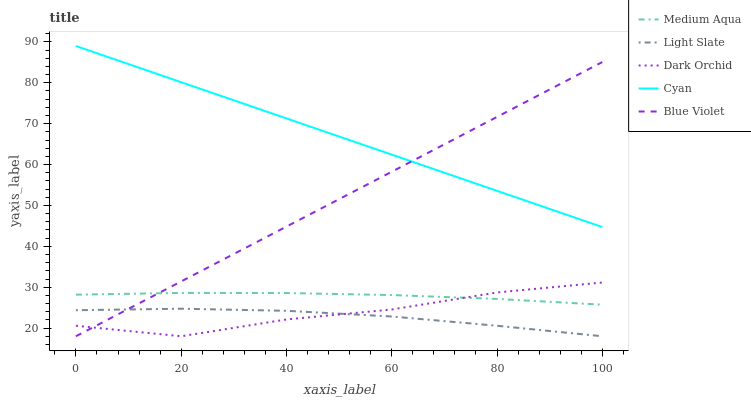Does Light Slate have the minimum area under the curve?
Answer yes or no. Yes. Does Cyan have the maximum area under the curve?
Answer yes or no. Yes. Does Medium Aqua have the minimum area under the curve?
Answer yes or no. No. Does Medium Aqua have the maximum area under the curve?
Answer yes or no. No. Is Blue Violet the smoothest?
Answer yes or no. Yes. Is Dark Orchid the roughest?
Answer yes or no. Yes. Is Cyan the smoothest?
Answer yes or no. No. Is Cyan the roughest?
Answer yes or no. No. Does Medium Aqua have the lowest value?
Answer yes or no. No. Does Cyan have the highest value?
Answer yes or no. Yes. Does Medium Aqua have the highest value?
Answer yes or no. No. Is Light Slate less than Cyan?
Answer yes or no. Yes. Is Cyan greater than Dark Orchid?
Answer yes or no. Yes. Does Dark Orchid intersect Light Slate?
Answer yes or no. Yes. Is Dark Orchid less than Light Slate?
Answer yes or no. No. Is Dark Orchid greater than Light Slate?
Answer yes or no. No. Does Light Slate intersect Cyan?
Answer yes or no. No. 